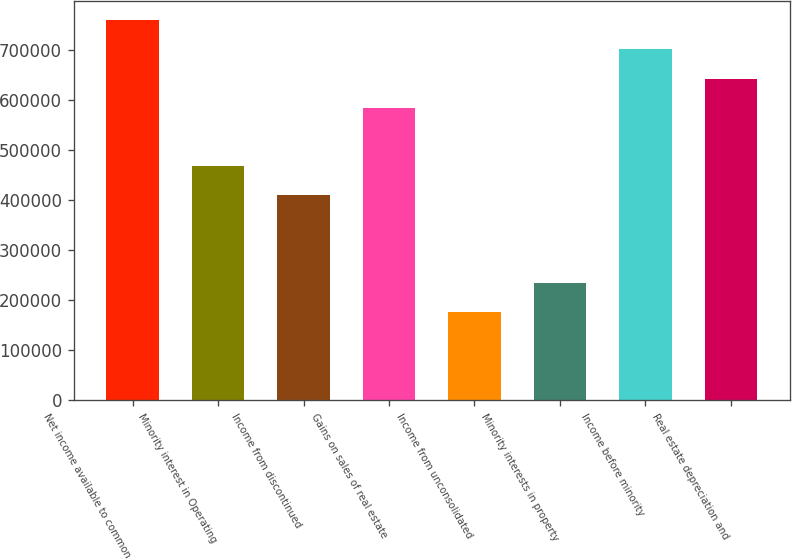Convert chart. <chart><loc_0><loc_0><loc_500><loc_500><bar_chart><fcel>Net income available to common<fcel>Minority interest in Operating<fcel>Income from discontinued<fcel>Gains on sales of real estate<fcel>Income from unconsolidated<fcel>Minority interests in property<fcel>Income before minority<fcel>Real estate depreciation and<nl><fcel>759068<fcel>467151<fcel>408768<fcel>583918<fcel>175234<fcel>233617<fcel>700685<fcel>642301<nl></chart> 